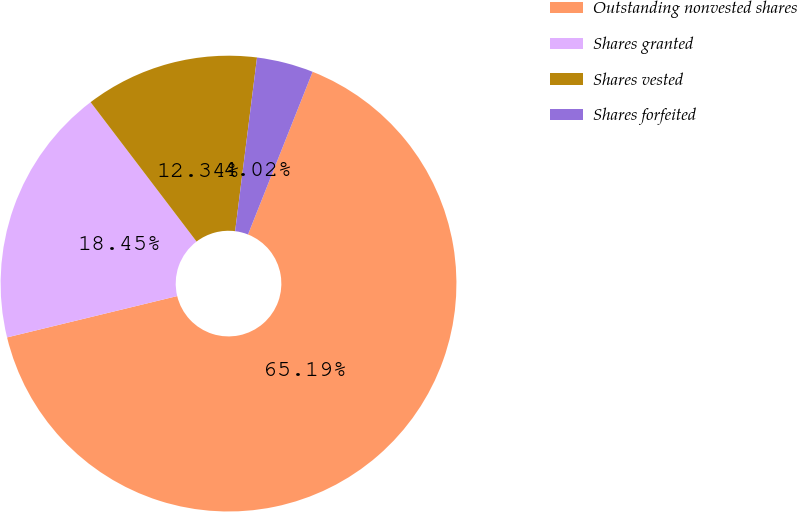<chart> <loc_0><loc_0><loc_500><loc_500><pie_chart><fcel>Outstanding nonvested shares<fcel>Shares granted<fcel>Shares vested<fcel>Shares forfeited<nl><fcel>65.19%<fcel>18.45%<fcel>12.34%<fcel>4.02%<nl></chart> 